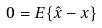<formula> <loc_0><loc_0><loc_500><loc_500>0 = E \{ \hat { x } - x \}</formula> 